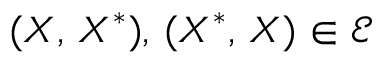<formula> <loc_0><loc_0><loc_500><loc_500>( X , \, X ^ { \ast } ) , \, ( X ^ { \ast } , \, X ) \in \mathcal { E }</formula> 